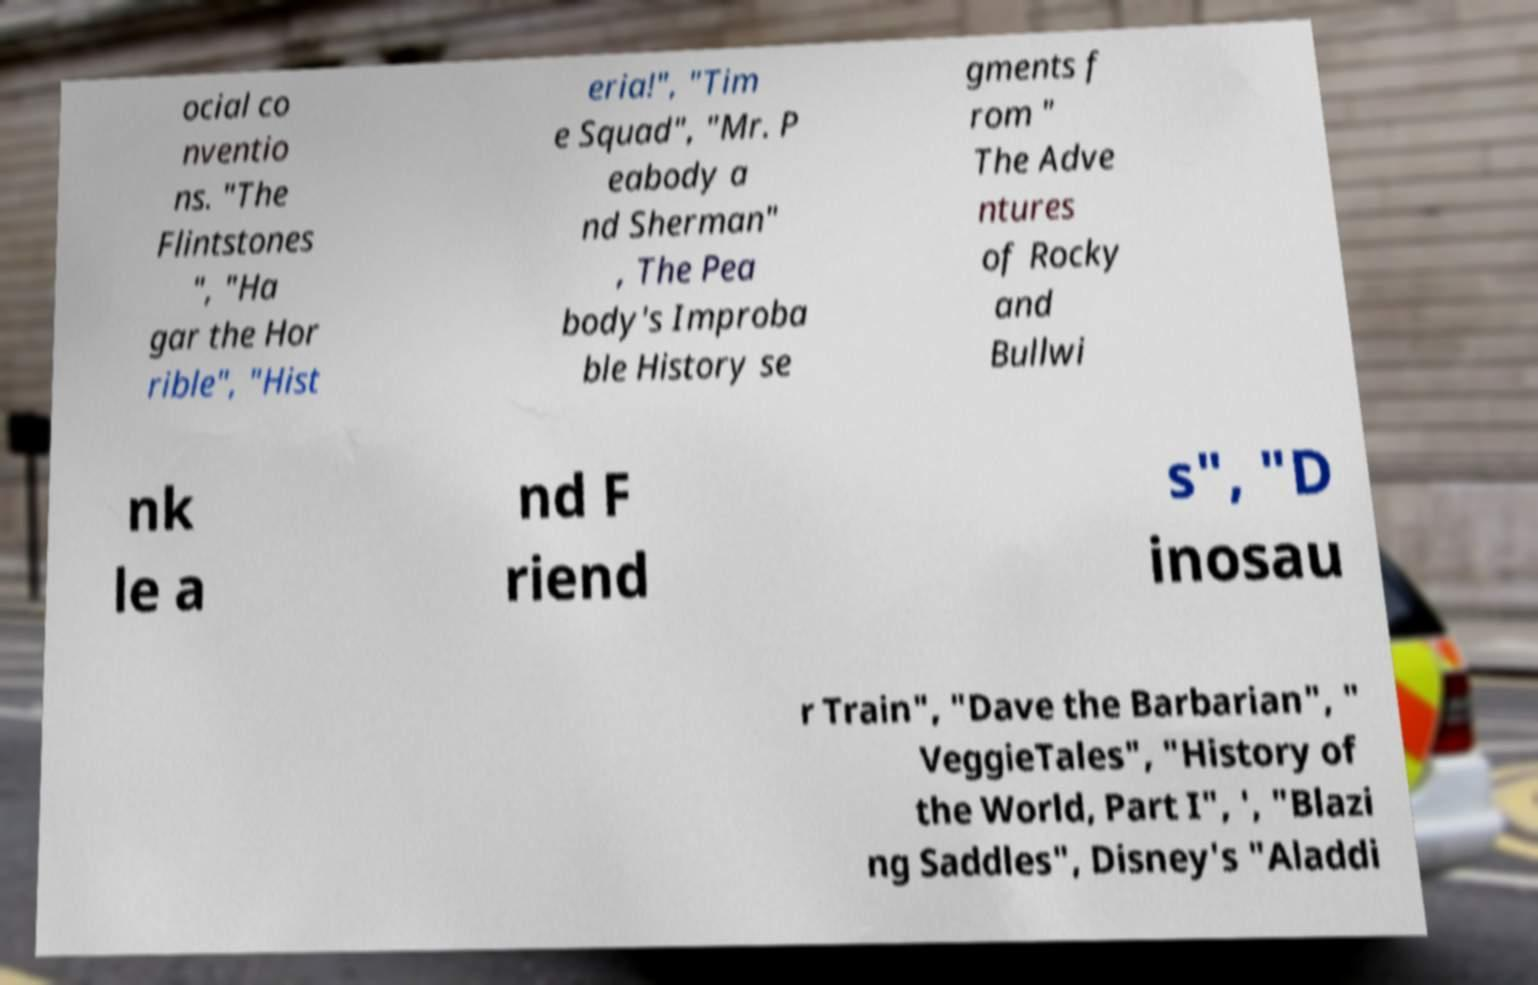Please identify and transcribe the text found in this image. ocial co nventio ns. "The Flintstones ", "Ha gar the Hor rible", "Hist eria!", "Tim e Squad", "Mr. P eabody a nd Sherman" , The Pea body's Improba ble History se gments f rom " The Adve ntures of Rocky and Bullwi nk le a nd F riend s", "D inosau r Train", "Dave the Barbarian", " VeggieTales", "History of the World, Part I", ', "Blazi ng Saddles", Disney's "Aladdi 